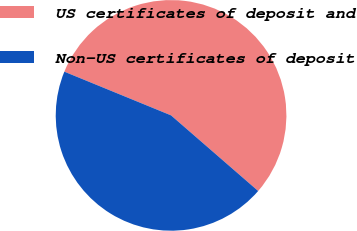<chart> <loc_0><loc_0><loc_500><loc_500><pie_chart><fcel>US certificates of deposit and<fcel>Non-US certificates of deposit<nl><fcel>55.19%<fcel>44.81%<nl></chart> 